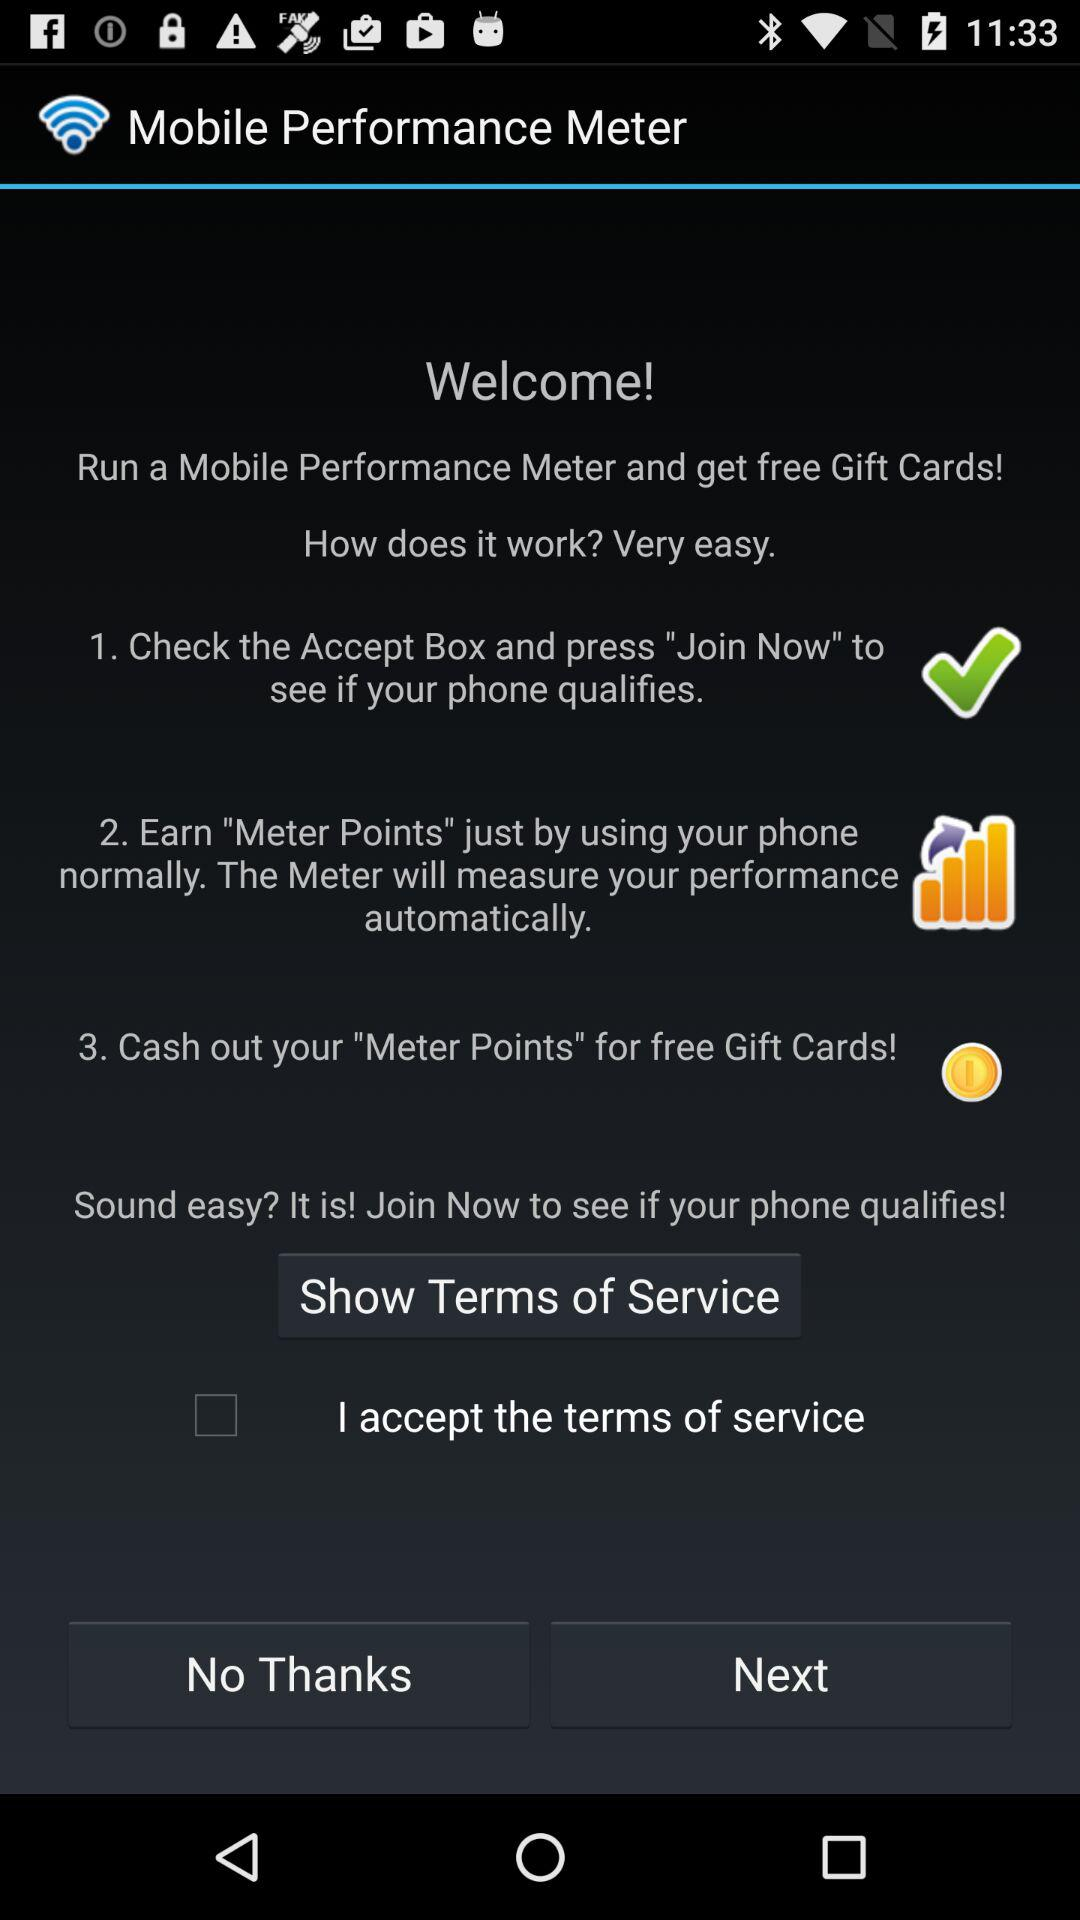What is the status of "I accept the terms of service"? The status is "off". 